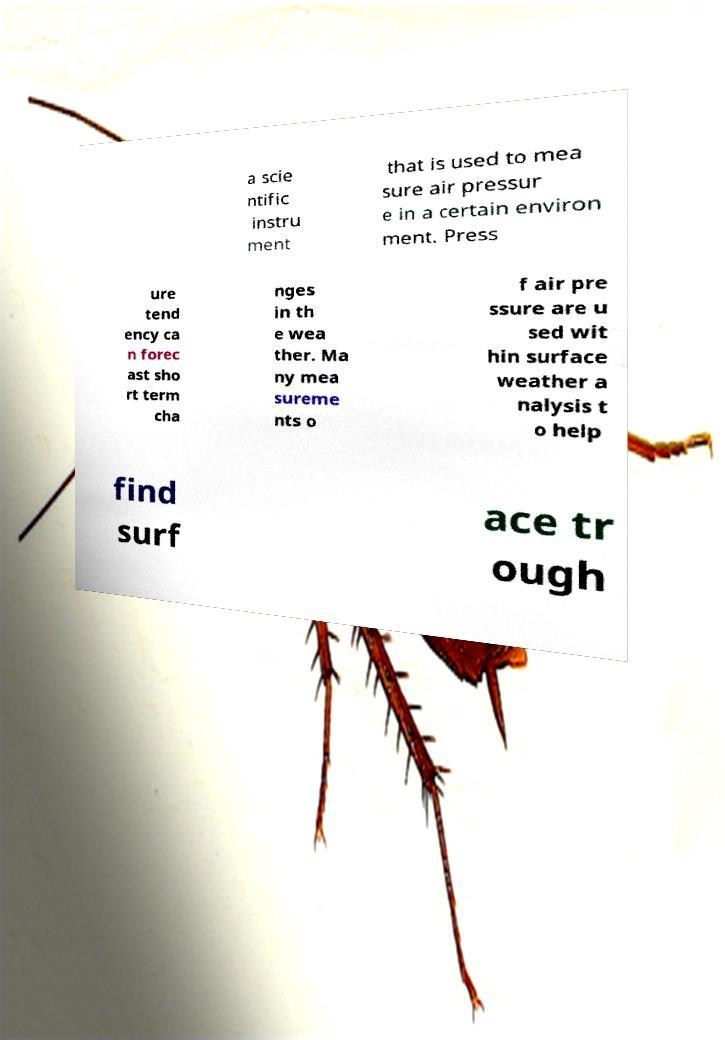Can you read and provide the text displayed in the image?This photo seems to have some interesting text. Can you extract and type it out for me? a scie ntific instru ment that is used to mea sure air pressur e in a certain environ ment. Press ure tend ency ca n forec ast sho rt term cha nges in th e wea ther. Ma ny mea sureme nts o f air pre ssure are u sed wit hin surface weather a nalysis t o help find surf ace tr ough 